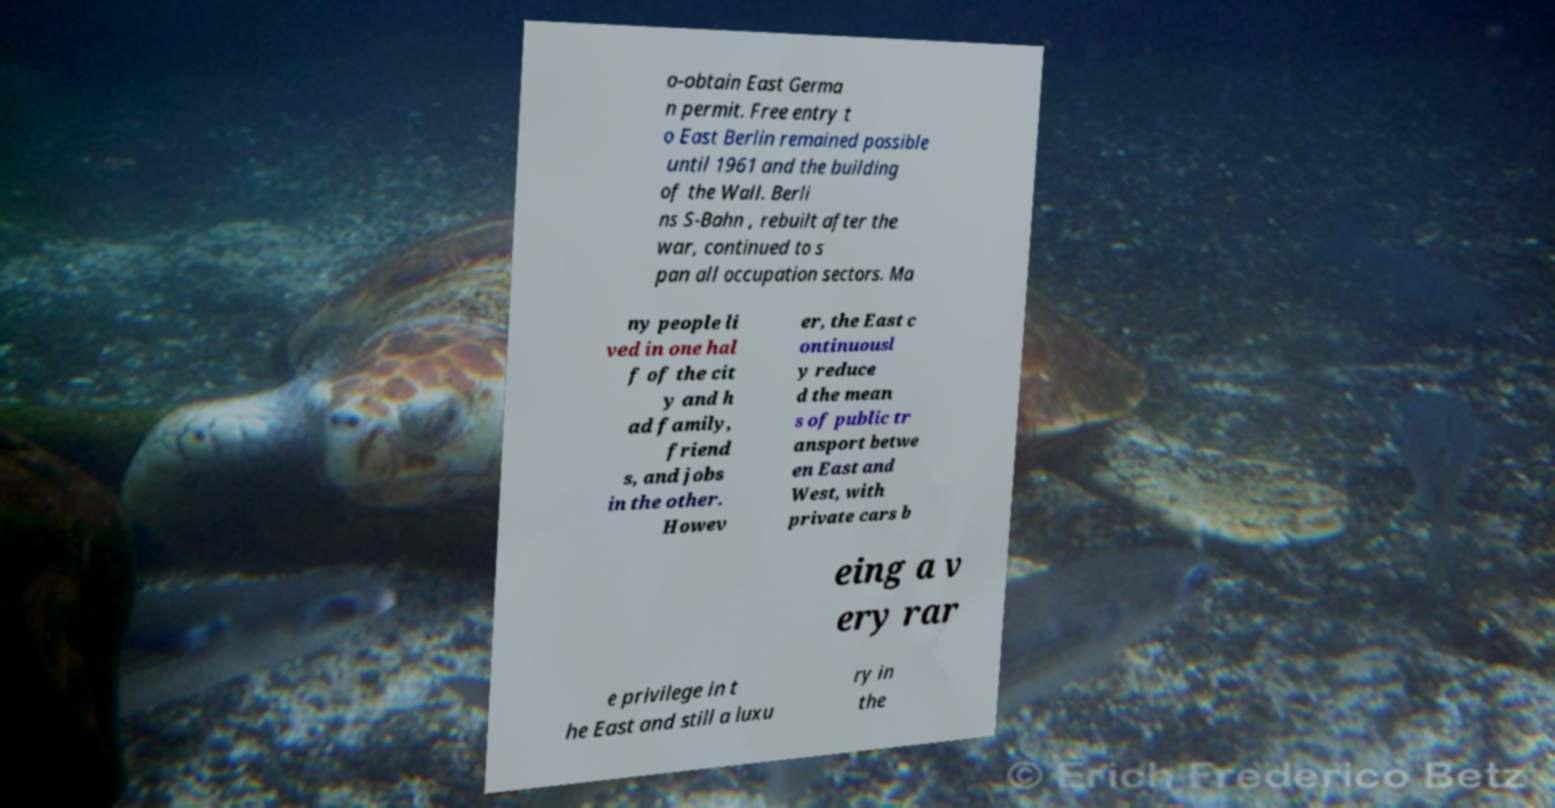What messages or text are displayed in this image? I need them in a readable, typed format. o-obtain East Germa n permit. Free entry t o East Berlin remained possible until 1961 and the building of the Wall. Berli ns S-Bahn , rebuilt after the war, continued to s pan all occupation sectors. Ma ny people li ved in one hal f of the cit y and h ad family, friend s, and jobs in the other. Howev er, the East c ontinuousl y reduce d the mean s of public tr ansport betwe en East and West, with private cars b eing a v ery rar e privilege in t he East and still a luxu ry in the 